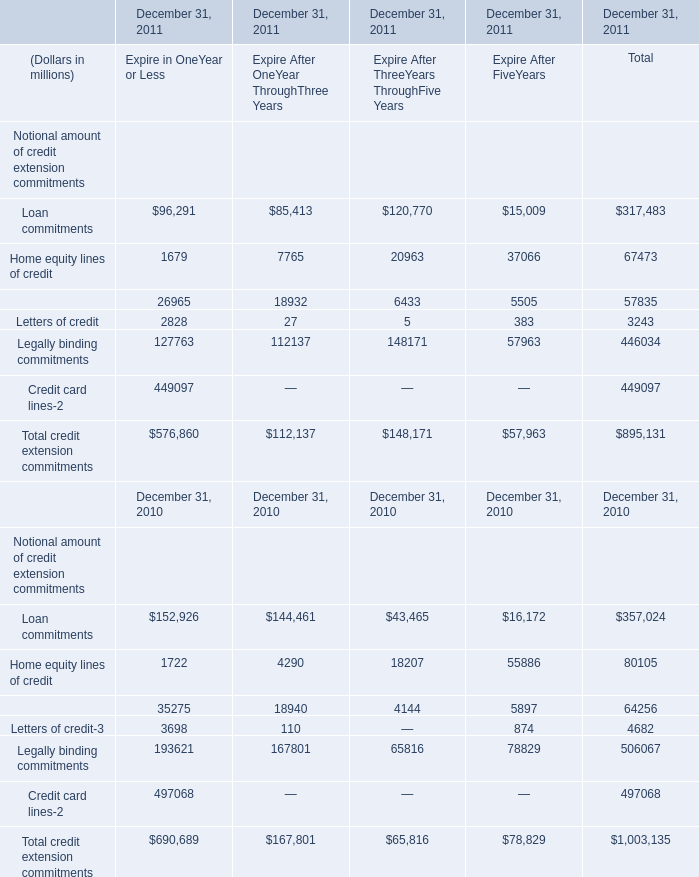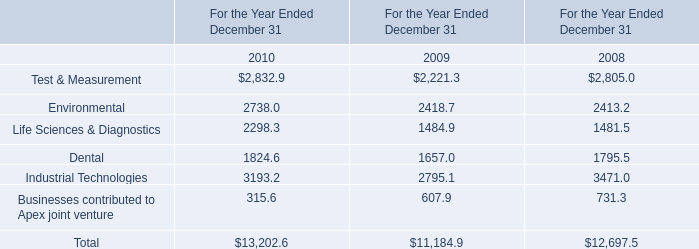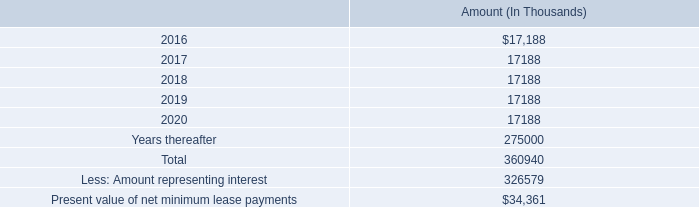What is the growing rate of Dental in Table 1 in the year with the most Letters of credit of Expire in OneYear or Less in Table 0? 
Computations: ((1824.6 - 1657) / 1657)
Answer: 0.10115. 